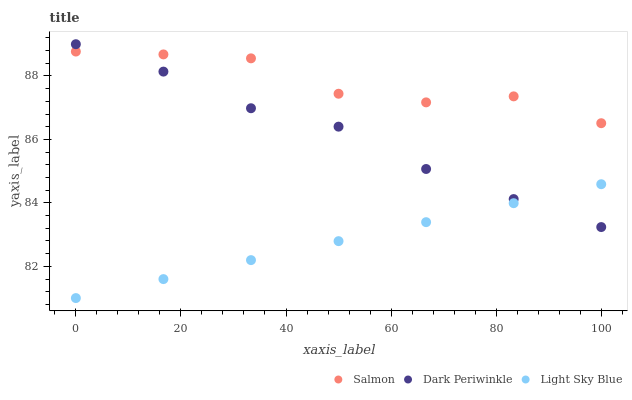Does Light Sky Blue have the minimum area under the curve?
Answer yes or no. Yes. Does Salmon have the maximum area under the curve?
Answer yes or no. Yes. Does Dark Periwinkle have the minimum area under the curve?
Answer yes or no. No. Does Dark Periwinkle have the maximum area under the curve?
Answer yes or no. No. Is Light Sky Blue the smoothest?
Answer yes or no. Yes. Is Salmon the roughest?
Answer yes or no. Yes. Is Dark Periwinkle the smoothest?
Answer yes or no. No. Is Dark Periwinkle the roughest?
Answer yes or no. No. Does Light Sky Blue have the lowest value?
Answer yes or no. Yes. Does Dark Periwinkle have the lowest value?
Answer yes or no. No. Does Dark Periwinkle have the highest value?
Answer yes or no. Yes. Does Salmon have the highest value?
Answer yes or no. No. Is Light Sky Blue less than Salmon?
Answer yes or no. Yes. Is Salmon greater than Light Sky Blue?
Answer yes or no. Yes. Does Salmon intersect Dark Periwinkle?
Answer yes or no. Yes. Is Salmon less than Dark Periwinkle?
Answer yes or no. No. Is Salmon greater than Dark Periwinkle?
Answer yes or no. No. Does Light Sky Blue intersect Salmon?
Answer yes or no. No. 